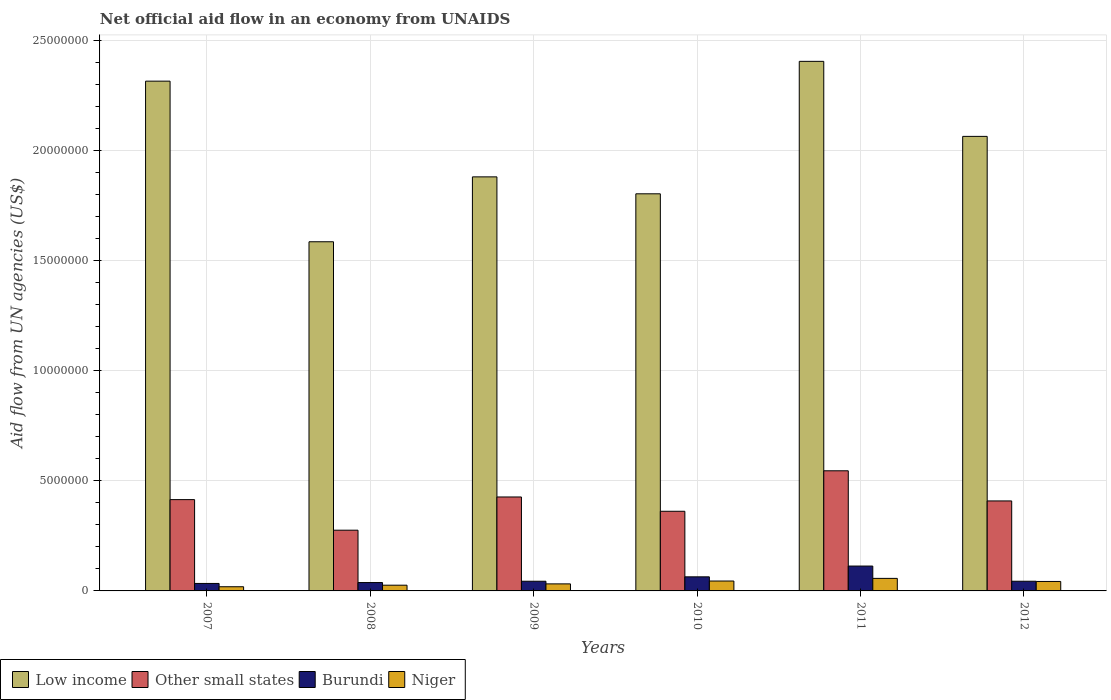How many different coloured bars are there?
Your answer should be compact. 4. How many groups of bars are there?
Your response must be concise. 6. In how many cases, is the number of bars for a given year not equal to the number of legend labels?
Give a very brief answer. 0. What is the net official aid flow in Niger in 2008?
Give a very brief answer. 2.60e+05. Across all years, what is the maximum net official aid flow in Niger?
Your answer should be very brief. 5.70e+05. Across all years, what is the minimum net official aid flow in Low income?
Provide a succinct answer. 1.59e+07. What is the total net official aid flow in Low income in the graph?
Make the answer very short. 1.21e+08. What is the difference between the net official aid flow in Burundi in 2007 and that in 2011?
Ensure brevity in your answer.  -7.90e+05. What is the difference between the net official aid flow in Niger in 2008 and the net official aid flow in Other small states in 2011?
Offer a very short reply. -5.20e+06. What is the average net official aid flow in Other small states per year?
Give a very brief answer. 4.06e+06. In the year 2008, what is the difference between the net official aid flow in Low income and net official aid flow in Niger?
Keep it short and to the point. 1.56e+07. What is the ratio of the net official aid flow in Low income in 2010 to that in 2011?
Your response must be concise. 0.75. Is the net official aid flow in Burundi in 2011 less than that in 2012?
Offer a very short reply. No. Is the difference between the net official aid flow in Low income in 2007 and 2010 greater than the difference between the net official aid flow in Niger in 2007 and 2010?
Your answer should be compact. Yes. What is the difference between the highest and the lowest net official aid flow in Other small states?
Keep it short and to the point. 2.70e+06. Is it the case that in every year, the sum of the net official aid flow in Burundi and net official aid flow in Low income is greater than the sum of net official aid flow in Other small states and net official aid flow in Niger?
Offer a terse response. Yes. What does the 2nd bar from the left in 2012 represents?
Give a very brief answer. Other small states. What does the 1st bar from the right in 2007 represents?
Your answer should be very brief. Niger. Is it the case that in every year, the sum of the net official aid flow in Low income and net official aid flow in Burundi is greater than the net official aid flow in Other small states?
Provide a short and direct response. Yes. Are all the bars in the graph horizontal?
Make the answer very short. No. How many years are there in the graph?
Give a very brief answer. 6. Does the graph contain any zero values?
Provide a short and direct response. No. Does the graph contain grids?
Offer a terse response. Yes. What is the title of the graph?
Give a very brief answer. Net official aid flow in an economy from UNAIDS. What is the label or title of the X-axis?
Make the answer very short. Years. What is the label or title of the Y-axis?
Your answer should be compact. Aid flow from UN agencies (US$). What is the Aid flow from UN agencies (US$) of Low income in 2007?
Ensure brevity in your answer.  2.32e+07. What is the Aid flow from UN agencies (US$) in Other small states in 2007?
Keep it short and to the point. 4.15e+06. What is the Aid flow from UN agencies (US$) of Low income in 2008?
Your answer should be very brief. 1.59e+07. What is the Aid flow from UN agencies (US$) in Other small states in 2008?
Keep it short and to the point. 2.76e+06. What is the Aid flow from UN agencies (US$) in Burundi in 2008?
Make the answer very short. 3.80e+05. What is the Aid flow from UN agencies (US$) of Low income in 2009?
Offer a terse response. 1.88e+07. What is the Aid flow from UN agencies (US$) in Other small states in 2009?
Your answer should be very brief. 4.27e+06. What is the Aid flow from UN agencies (US$) of Niger in 2009?
Make the answer very short. 3.20e+05. What is the Aid flow from UN agencies (US$) of Low income in 2010?
Offer a terse response. 1.80e+07. What is the Aid flow from UN agencies (US$) of Other small states in 2010?
Offer a terse response. 3.62e+06. What is the Aid flow from UN agencies (US$) of Burundi in 2010?
Make the answer very short. 6.40e+05. What is the Aid flow from UN agencies (US$) in Low income in 2011?
Make the answer very short. 2.41e+07. What is the Aid flow from UN agencies (US$) of Other small states in 2011?
Provide a succinct answer. 5.46e+06. What is the Aid flow from UN agencies (US$) of Burundi in 2011?
Your answer should be compact. 1.13e+06. What is the Aid flow from UN agencies (US$) of Niger in 2011?
Give a very brief answer. 5.70e+05. What is the Aid flow from UN agencies (US$) in Low income in 2012?
Offer a very short reply. 2.07e+07. What is the Aid flow from UN agencies (US$) in Other small states in 2012?
Your response must be concise. 4.09e+06. Across all years, what is the maximum Aid flow from UN agencies (US$) of Low income?
Provide a succinct answer. 2.41e+07. Across all years, what is the maximum Aid flow from UN agencies (US$) in Other small states?
Offer a very short reply. 5.46e+06. Across all years, what is the maximum Aid flow from UN agencies (US$) in Burundi?
Ensure brevity in your answer.  1.13e+06. Across all years, what is the maximum Aid flow from UN agencies (US$) in Niger?
Your answer should be compact. 5.70e+05. Across all years, what is the minimum Aid flow from UN agencies (US$) of Low income?
Offer a very short reply. 1.59e+07. Across all years, what is the minimum Aid flow from UN agencies (US$) of Other small states?
Your answer should be very brief. 2.76e+06. What is the total Aid flow from UN agencies (US$) in Low income in the graph?
Make the answer very short. 1.21e+08. What is the total Aid flow from UN agencies (US$) in Other small states in the graph?
Provide a short and direct response. 2.44e+07. What is the total Aid flow from UN agencies (US$) of Burundi in the graph?
Your answer should be very brief. 3.37e+06. What is the total Aid flow from UN agencies (US$) of Niger in the graph?
Provide a succinct answer. 2.22e+06. What is the difference between the Aid flow from UN agencies (US$) in Low income in 2007 and that in 2008?
Your answer should be compact. 7.30e+06. What is the difference between the Aid flow from UN agencies (US$) of Other small states in 2007 and that in 2008?
Provide a succinct answer. 1.39e+06. What is the difference between the Aid flow from UN agencies (US$) of Niger in 2007 and that in 2008?
Make the answer very short. -7.00e+04. What is the difference between the Aid flow from UN agencies (US$) in Low income in 2007 and that in 2009?
Offer a terse response. 4.35e+06. What is the difference between the Aid flow from UN agencies (US$) in Burundi in 2007 and that in 2009?
Keep it short and to the point. -1.00e+05. What is the difference between the Aid flow from UN agencies (US$) of Niger in 2007 and that in 2009?
Ensure brevity in your answer.  -1.30e+05. What is the difference between the Aid flow from UN agencies (US$) of Low income in 2007 and that in 2010?
Offer a terse response. 5.12e+06. What is the difference between the Aid flow from UN agencies (US$) in Other small states in 2007 and that in 2010?
Your response must be concise. 5.30e+05. What is the difference between the Aid flow from UN agencies (US$) in Low income in 2007 and that in 2011?
Ensure brevity in your answer.  -9.00e+05. What is the difference between the Aid flow from UN agencies (US$) of Other small states in 2007 and that in 2011?
Make the answer very short. -1.31e+06. What is the difference between the Aid flow from UN agencies (US$) in Burundi in 2007 and that in 2011?
Provide a succinct answer. -7.90e+05. What is the difference between the Aid flow from UN agencies (US$) of Niger in 2007 and that in 2011?
Your answer should be compact. -3.80e+05. What is the difference between the Aid flow from UN agencies (US$) in Low income in 2007 and that in 2012?
Keep it short and to the point. 2.51e+06. What is the difference between the Aid flow from UN agencies (US$) of Low income in 2008 and that in 2009?
Give a very brief answer. -2.95e+06. What is the difference between the Aid flow from UN agencies (US$) in Other small states in 2008 and that in 2009?
Keep it short and to the point. -1.51e+06. What is the difference between the Aid flow from UN agencies (US$) in Burundi in 2008 and that in 2009?
Provide a succinct answer. -6.00e+04. What is the difference between the Aid flow from UN agencies (US$) of Niger in 2008 and that in 2009?
Make the answer very short. -6.00e+04. What is the difference between the Aid flow from UN agencies (US$) of Low income in 2008 and that in 2010?
Your response must be concise. -2.18e+06. What is the difference between the Aid flow from UN agencies (US$) in Other small states in 2008 and that in 2010?
Provide a short and direct response. -8.60e+05. What is the difference between the Aid flow from UN agencies (US$) of Niger in 2008 and that in 2010?
Your response must be concise. -1.90e+05. What is the difference between the Aid flow from UN agencies (US$) in Low income in 2008 and that in 2011?
Make the answer very short. -8.20e+06. What is the difference between the Aid flow from UN agencies (US$) in Other small states in 2008 and that in 2011?
Provide a short and direct response. -2.70e+06. What is the difference between the Aid flow from UN agencies (US$) of Burundi in 2008 and that in 2011?
Keep it short and to the point. -7.50e+05. What is the difference between the Aid flow from UN agencies (US$) of Niger in 2008 and that in 2011?
Provide a succinct answer. -3.10e+05. What is the difference between the Aid flow from UN agencies (US$) in Low income in 2008 and that in 2012?
Keep it short and to the point. -4.79e+06. What is the difference between the Aid flow from UN agencies (US$) of Other small states in 2008 and that in 2012?
Your answer should be very brief. -1.33e+06. What is the difference between the Aid flow from UN agencies (US$) of Burundi in 2008 and that in 2012?
Make the answer very short. -6.00e+04. What is the difference between the Aid flow from UN agencies (US$) in Niger in 2008 and that in 2012?
Offer a terse response. -1.70e+05. What is the difference between the Aid flow from UN agencies (US$) of Low income in 2009 and that in 2010?
Your answer should be very brief. 7.70e+05. What is the difference between the Aid flow from UN agencies (US$) in Other small states in 2009 and that in 2010?
Your answer should be compact. 6.50e+05. What is the difference between the Aid flow from UN agencies (US$) in Burundi in 2009 and that in 2010?
Make the answer very short. -2.00e+05. What is the difference between the Aid flow from UN agencies (US$) in Low income in 2009 and that in 2011?
Ensure brevity in your answer.  -5.25e+06. What is the difference between the Aid flow from UN agencies (US$) in Other small states in 2009 and that in 2011?
Provide a succinct answer. -1.19e+06. What is the difference between the Aid flow from UN agencies (US$) in Burundi in 2009 and that in 2011?
Give a very brief answer. -6.90e+05. What is the difference between the Aid flow from UN agencies (US$) in Niger in 2009 and that in 2011?
Make the answer very short. -2.50e+05. What is the difference between the Aid flow from UN agencies (US$) in Low income in 2009 and that in 2012?
Make the answer very short. -1.84e+06. What is the difference between the Aid flow from UN agencies (US$) in Low income in 2010 and that in 2011?
Make the answer very short. -6.02e+06. What is the difference between the Aid flow from UN agencies (US$) of Other small states in 2010 and that in 2011?
Provide a succinct answer. -1.84e+06. What is the difference between the Aid flow from UN agencies (US$) of Burundi in 2010 and that in 2011?
Provide a succinct answer. -4.90e+05. What is the difference between the Aid flow from UN agencies (US$) of Low income in 2010 and that in 2012?
Keep it short and to the point. -2.61e+06. What is the difference between the Aid flow from UN agencies (US$) of Other small states in 2010 and that in 2012?
Make the answer very short. -4.70e+05. What is the difference between the Aid flow from UN agencies (US$) in Niger in 2010 and that in 2012?
Offer a terse response. 2.00e+04. What is the difference between the Aid flow from UN agencies (US$) in Low income in 2011 and that in 2012?
Provide a short and direct response. 3.41e+06. What is the difference between the Aid flow from UN agencies (US$) in Other small states in 2011 and that in 2012?
Your answer should be compact. 1.37e+06. What is the difference between the Aid flow from UN agencies (US$) in Burundi in 2011 and that in 2012?
Provide a succinct answer. 6.90e+05. What is the difference between the Aid flow from UN agencies (US$) in Low income in 2007 and the Aid flow from UN agencies (US$) in Other small states in 2008?
Your response must be concise. 2.04e+07. What is the difference between the Aid flow from UN agencies (US$) in Low income in 2007 and the Aid flow from UN agencies (US$) in Burundi in 2008?
Offer a terse response. 2.28e+07. What is the difference between the Aid flow from UN agencies (US$) in Low income in 2007 and the Aid flow from UN agencies (US$) in Niger in 2008?
Your answer should be compact. 2.29e+07. What is the difference between the Aid flow from UN agencies (US$) in Other small states in 2007 and the Aid flow from UN agencies (US$) in Burundi in 2008?
Your answer should be compact. 3.77e+06. What is the difference between the Aid flow from UN agencies (US$) of Other small states in 2007 and the Aid flow from UN agencies (US$) of Niger in 2008?
Ensure brevity in your answer.  3.89e+06. What is the difference between the Aid flow from UN agencies (US$) of Low income in 2007 and the Aid flow from UN agencies (US$) of Other small states in 2009?
Offer a terse response. 1.89e+07. What is the difference between the Aid flow from UN agencies (US$) of Low income in 2007 and the Aid flow from UN agencies (US$) of Burundi in 2009?
Offer a very short reply. 2.27e+07. What is the difference between the Aid flow from UN agencies (US$) of Low income in 2007 and the Aid flow from UN agencies (US$) of Niger in 2009?
Make the answer very short. 2.28e+07. What is the difference between the Aid flow from UN agencies (US$) of Other small states in 2007 and the Aid flow from UN agencies (US$) of Burundi in 2009?
Offer a very short reply. 3.71e+06. What is the difference between the Aid flow from UN agencies (US$) of Other small states in 2007 and the Aid flow from UN agencies (US$) of Niger in 2009?
Your answer should be compact. 3.83e+06. What is the difference between the Aid flow from UN agencies (US$) in Burundi in 2007 and the Aid flow from UN agencies (US$) in Niger in 2009?
Provide a short and direct response. 2.00e+04. What is the difference between the Aid flow from UN agencies (US$) of Low income in 2007 and the Aid flow from UN agencies (US$) of Other small states in 2010?
Your answer should be very brief. 1.96e+07. What is the difference between the Aid flow from UN agencies (US$) of Low income in 2007 and the Aid flow from UN agencies (US$) of Burundi in 2010?
Ensure brevity in your answer.  2.25e+07. What is the difference between the Aid flow from UN agencies (US$) of Low income in 2007 and the Aid flow from UN agencies (US$) of Niger in 2010?
Provide a succinct answer. 2.27e+07. What is the difference between the Aid flow from UN agencies (US$) in Other small states in 2007 and the Aid flow from UN agencies (US$) in Burundi in 2010?
Offer a very short reply. 3.51e+06. What is the difference between the Aid flow from UN agencies (US$) in Other small states in 2007 and the Aid flow from UN agencies (US$) in Niger in 2010?
Provide a short and direct response. 3.70e+06. What is the difference between the Aid flow from UN agencies (US$) of Burundi in 2007 and the Aid flow from UN agencies (US$) of Niger in 2010?
Give a very brief answer. -1.10e+05. What is the difference between the Aid flow from UN agencies (US$) of Low income in 2007 and the Aid flow from UN agencies (US$) of Other small states in 2011?
Offer a very short reply. 1.77e+07. What is the difference between the Aid flow from UN agencies (US$) of Low income in 2007 and the Aid flow from UN agencies (US$) of Burundi in 2011?
Your answer should be compact. 2.20e+07. What is the difference between the Aid flow from UN agencies (US$) in Low income in 2007 and the Aid flow from UN agencies (US$) in Niger in 2011?
Your answer should be very brief. 2.26e+07. What is the difference between the Aid flow from UN agencies (US$) of Other small states in 2007 and the Aid flow from UN agencies (US$) of Burundi in 2011?
Ensure brevity in your answer.  3.02e+06. What is the difference between the Aid flow from UN agencies (US$) in Other small states in 2007 and the Aid flow from UN agencies (US$) in Niger in 2011?
Offer a terse response. 3.58e+06. What is the difference between the Aid flow from UN agencies (US$) in Burundi in 2007 and the Aid flow from UN agencies (US$) in Niger in 2011?
Offer a very short reply. -2.30e+05. What is the difference between the Aid flow from UN agencies (US$) of Low income in 2007 and the Aid flow from UN agencies (US$) of Other small states in 2012?
Your answer should be compact. 1.91e+07. What is the difference between the Aid flow from UN agencies (US$) in Low income in 2007 and the Aid flow from UN agencies (US$) in Burundi in 2012?
Your answer should be very brief. 2.27e+07. What is the difference between the Aid flow from UN agencies (US$) in Low income in 2007 and the Aid flow from UN agencies (US$) in Niger in 2012?
Keep it short and to the point. 2.27e+07. What is the difference between the Aid flow from UN agencies (US$) in Other small states in 2007 and the Aid flow from UN agencies (US$) in Burundi in 2012?
Your answer should be very brief. 3.71e+06. What is the difference between the Aid flow from UN agencies (US$) in Other small states in 2007 and the Aid flow from UN agencies (US$) in Niger in 2012?
Ensure brevity in your answer.  3.72e+06. What is the difference between the Aid flow from UN agencies (US$) of Low income in 2008 and the Aid flow from UN agencies (US$) of Other small states in 2009?
Your response must be concise. 1.16e+07. What is the difference between the Aid flow from UN agencies (US$) in Low income in 2008 and the Aid flow from UN agencies (US$) in Burundi in 2009?
Offer a very short reply. 1.54e+07. What is the difference between the Aid flow from UN agencies (US$) in Low income in 2008 and the Aid flow from UN agencies (US$) in Niger in 2009?
Give a very brief answer. 1.56e+07. What is the difference between the Aid flow from UN agencies (US$) in Other small states in 2008 and the Aid flow from UN agencies (US$) in Burundi in 2009?
Keep it short and to the point. 2.32e+06. What is the difference between the Aid flow from UN agencies (US$) in Other small states in 2008 and the Aid flow from UN agencies (US$) in Niger in 2009?
Provide a succinct answer. 2.44e+06. What is the difference between the Aid flow from UN agencies (US$) in Burundi in 2008 and the Aid flow from UN agencies (US$) in Niger in 2009?
Your response must be concise. 6.00e+04. What is the difference between the Aid flow from UN agencies (US$) of Low income in 2008 and the Aid flow from UN agencies (US$) of Other small states in 2010?
Offer a very short reply. 1.22e+07. What is the difference between the Aid flow from UN agencies (US$) in Low income in 2008 and the Aid flow from UN agencies (US$) in Burundi in 2010?
Offer a very short reply. 1.52e+07. What is the difference between the Aid flow from UN agencies (US$) in Low income in 2008 and the Aid flow from UN agencies (US$) in Niger in 2010?
Your answer should be very brief. 1.54e+07. What is the difference between the Aid flow from UN agencies (US$) of Other small states in 2008 and the Aid flow from UN agencies (US$) of Burundi in 2010?
Your answer should be very brief. 2.12e+06. What is the difference between the Aid flow from UN agencies (US$) in Other small states in 2008 and the Aid flow from UN agencies (US$) in Niger in 2010?
Your response must be concise. 2.31e+06. What is the difference between the Aid flow from UN agencies (US$) in Burundi in 2008 and the Aid flow from UN agencies (US$) in Niger in 2010?
Your answer should be very brief. -7.00e+04. What is the difference between the Aid flow from UN agencies (US$) of Low income in 2008 and the Aid flow from UN agencies (US$) of Other small states in 2011?
Provide a succinct answer. 1.04e+07. What is the difference between the Aid flow from UN agencies (US$) in Low income in 2008 and the Aid flow from UN agencies (US$) in Burundi in 2011?
Your answer should be compact. 1.47e+07. What is the difference between the Aid flow from UN agencies (US$) in Low income in 2008 and the Aid flow from UN agencies (US$) in Niger in 2011?
Provide a short and direct response. 1.53e+07. What is the difference between the Aid flow from UN agencies (US$) of Other small states in 2008 and the Aid flow from UN agencies (US$) of Burundi in 2011?
Your answer should be compact. 1.63e+06. What is the difference between the Aid flow from UN agencies (US$) in Other small states in 2008 and the Aid flow from UN agencies (US$) in Niger in 2011?
Provide a short and direct response. 2.19e+06. What is the difference between the Aid flow from UN agencies (US$) of Burundi in 2008 and the Aid flow from UN agencies (US$) of Niger in 2011?
Offer a very short reply. -1.90e+05. What is the difference between the Aid flow from UN agencies (US$) in Low income in 2008 and the Aid flow from UN agencies (US$) in Other small states in 2012?
Your response must be concise. 1.18e+07. What is the difference between the Aid flow from UN agencies (US$) of Low income in 2008 and the Aid flow from UN agencies (US$) of Burundi in 2012?
Your answer should be very brief. 1.54e+07. What is the difference between the Aid flow from UN agencies (US$) of Low income in 2008 and the Aid flow from UN agencies (US$) of Niger in 2012?
Keep it short and to the point. 1.54e+07. What is the difference between the Aid flow from UN agencies (US$) of Other small states in 2008 and the Aid flow from UN agencies (US$) of Burundi in 2012?
Offer a terse response. 2.32e+06. What is the difference between the Aid flow from UN agencies (US$) in Other small states in 2008 and the Aid flow from UN agencies (US$) in Niger in 2012?
Provide a short and direct response. 2.33e+06. What is the difference between the Aid flow from UN agencies (US$) of Low income in 2009 and the Aid flow from UN agencies (US$) of Other small states in 2010?
Your answer should be compact. 1.52e+07. What is the difference between the Aid flow from UN agencies (US$) of Low income in 2009 and the Aid flow from UN agencies (US$) of Burundi in 2010?
Give a very brief answer. 1.82e+07. What is the difference between the Aid flow from UN agencies (US$) in Low income in 2009 and the Aid flow from UN agencies (US$) in Niger in 2010?
Offer a terse response. 1.84e+07. What is the difference between the Aid flow from UN agencies (US$) in Other small states in 2009 and the Aid flow from UN agencies (US$) in Burundi in 2010?
Ensure brevity in your answer.  3.63e+06. What is the difference between the Aid flow from UN agencies (US$) of Other small states in 2009 and the Aid flow from UN agencies (US$) of Niger in 2010?
Ensure brevity in your answer.  3.82e+06. What is the difference between the Aid flow from UN agencies (US$) of Low income in 2009 and the Aid flow from UN agencies (US$) of Other small states in 2011?
Your answer should be very brief. 1.34e+07. What is the difference between the Aid flow from UN agencies (US$) in Low income in 2009 and the Aid flow from UN agencies (US$) in Burundi in 2011?
Offer a very short reply. 1.77e+07. What is the difference between the Aid flow from UN agencies (US$) of Low income in 2009 and the Aid flow from UN agencies (US$) of Niger in 2011?
Offer a terse response. 1.82e+07. What is the difference between the Aid flow from UN agencies (US$) of Other small states in 2009 and the Aid flow from UN agencies (US$) of Burundi in 2011?
Your answer should be compact. 3.14e+06. What is the difference between the Aid flow from UN agencies (US$) of Other small states in 2009 and the Aid flow from UN agencies (US$) of Niger in 2011?
Provide a succinct answer. 3.70e+06. What is the difference between the Aid flow from UN agencies (US$) of Burundi in 2009 and the Aid flow from UN agencies (US$) of Niger in 2011?
Keep it short and to the point. -1.30e+05. What is the difference between the Aid flow from UN agencies (US$) in Low income in 2009 and the Aid flow from UN agencies (US$) in Other small states in 2012?
Your answer should be compact. 1.47e+07. What is the difference between the Aid flow from UN agencies (US$) of Low income in 2009 and the Aid flow from UN agencies (US$) of Burundi in 2012?
Keep it short and to the point. 1.84e+07. What is the difference between the Aid flow from UN agencies (US$) in Low income in 2009 and the Aid flow from UN agencies (US$) in Niger in 2012?
Ensure brevity in your answer.  1.84e+07. What is the difference between the Aid flow from UN agencies (US$) of Other small states in 2009 and the Aid flow from UN agencies (US$) of Burundi in 2012?
Keep it short and to the point. 3.83e+06. What is the difference between the Aid flow from UN agencies (US$) of Other small states in 2009 and the Aid flow from UN agencies (US$) of Niger in 2012?
Provide a short and direct response. 3.84e+06. What is the difference between the Aid flow from UN agencies (US$) of Low income in 2010 and the Aid flow from UN agencies (US$) of Other small states in 2011?
Offer a terse response. 1.26e+07. What is the difference between the Aid flow from UN agencies (US$) in Low income in 2010 and the Aid flow from UN agencies (US$) in Burundi in 2011?
Provide a succinct answer. 1.69e+07. What is the difference between the Aid flow from UN agencies (US$) in Low income in 2010 and the Aid flow from UN agencies (US$) in Niger in 2011?
Give a very brief answer. 1.75e+07. What is the difference between the Aid flow from UN agencies (US$) in Other small states in 2010 and the Aid flow from UN agencies (US$) in Burundi in 2011?
Provide a succinct answer. 2.49e+06. What is the difference between the Aid flow from UN agencies (US$) of Other small states in 2010 and the Aid flow from UN agencies (US$) of Niger in 2011?
Make the answer very short. 3.05e+06. What is the difference between the Aid flow from UN agencies (US$) of Burundi in 2010 and the Aid flow from UN agencies (US$) of Niger in 2011?
Your response must be concise. 7.00e+04. What is the difference between the Aid flow from UN agencies (US$) in Low income in 2010 and the Aid flow from UN agencies (US$) in Other small states in 2012?
Provide a succinct answer. 1.40e+07. What is the difference between the Aid flow from UN agencies (US$) in Low income in 2010 and the Aid flow from UN agencies (US$) in Burundi in 2012?
Keep it short and to the point. 1.76e+07. What is the difference between the Aid flow from UN agencies (US$) in Low income in 2010 and the Aid flow from UN agencies (US$) in Niger in 2012?
Ensure brevity in your answer.  1.76e+07. What is the difference between the Aid flow from UN agencies (US$) of Other small states in 2010 and the Aid flow from UN agencies (US$) of Burundi in 2012?
Make the answer very short. 3.18e+06. What is the difference between the Aid flow from UN agencies (US$) of Other small states in 2010 and the Aid flow from UN agencies (US$) of Niger in 2012?
Ensure brevity in your answer.  3.19e+06. What is the difference between the Aid flow from UN agencies (US$) of Burundi in 2010 and the Aid flow from UN agencies (US$) of Niger in 2012?
Provide a short and direct response. 2.10e+05. What is the difference between the Aid flow from UN agencies (US$) in Low income in 2011 and the Aid flow from UN agencies (US$) in Other small states in 2012?
Your answer should be compact. 2.00e+07. What is the difference between the Aid flow from UN agencies (US$) in Low income in 2011 and the Aid flow from UN agencies (US$) in Burundi in 2012?
Provide a short and direct response. 2.36e+07. What is the difference between the Aid flow from UN agencies (US$) of Low income in 2011 and the Aid flow from UN agencies (US$) of Niger in 2012?
Offer a very short reply. 2.36e+07. What is the difference between the Aid flow from UN agencies (US$) in Other small states in 2011 and the Aid flow from UN agencies (US$) in Burundi in 2012?
Your answer should be very brief. 5.02e+06. What is the difference between the Aid flow from UN agencies (US$) in Other small states in 2011 and the Aid flow from UN agencies (US$) in Niger in 2012?
Provide a succinct answer. 5.03e+06. What is the difference between the Aid flow from UN agencies (US$) in Burundi in 2011 and the Aid flow from UN agencies (US$) in Niger in 2012?
Provide a short and direct response. 7.00e+05. What is the average Aid flow from UN agencies (US$) in Low income per year?
Your answer should be very brief. 2.01e+07. What is the average Aid flow from UN agencies (US$) of Other small states per year?
Your answer should be very brief. 4.06e+06. What is the average Aid flow from UN agencies (US$) of Burundi per year?
Your answer should be very brief. 5.62e+05. In the year 2007, what is the difference between the Aid flow from UN agencies (US$) of Low income and Aid flow from UN agencies (US$) of Other small states?
Your response must be concise. 1.90e+07. In the year 2007, what is the difference between the Aid flow from UN agencies (US$) of Low income and Aid flow from UN agencies (US$) of Burundi?
Your answer should be compact. 2.28e+07. In the year 2007, what is the difference between the Aid flow from UN agencies (US$) of Low income and Aid flow from UN agencies (US$) of Niger?
Keep it short and to the point. 2.30e+07. In the year 2007, what is the difference between the Aid flow from UN agencies (US$) in Other small states and Aid flow from UN agencies (US$) in Burundi?
Provide a succinct answer. 3.81e+06. In the year 2007, what is the difference between the Aid flow from UN agencies (US$) in Other small states and Aid flow from UN agencies (US$) in Niger?
Make the answer very short. 3.96e+06. In the year 2008, what is the difference between the Aid flow from UN agencies (US$) in Low income and Aid flow from UN agencies (US$) in Other small states?
Provide a short and direct response. 1.31e+07. In the year 2008, what is the difference between the Aid flow from UN agencies (US$) in Low income and Aid flow from UN agencies (US$) in Burundi?
Provide a succinct answer. 1.55e+07. In the year 2008, what is the difference between the Aid flow from UN agencies (US$) of Low income and Aid flow from UN agencies (US$) of Niger?
Ensure brevity in your answer.  1.56e+07. In the year 2008, what is the difference between the Aid flow from UN agencies (US$) in Other small states and Aid flow from UN agencies (US$) in Burundi?
Make the answer very short. 2.38e+06. In the year 2008, what is the difference between the Aid flow from UN agencies (US$) in Other small states and Aid flow from UN agencies (US$) in Niger?
Your answer should be compact. 2.50e+06. In the year 2009, what is the difference between the Aid flow from UN agencies (US$) of Low income and Aid flow from UN agencies (US$) of Other small states?
Make the answer very short. 1.46e+07. In the year 2009, what is the difference between the Aid flow from UN agencies (US$) of Low income and Aid flow from UN agencies (US$) of Burundi?
Provide a succinct answer. 1.84e+07. In the year 2009, what is the difference between the Aid flow from UN agencies (US$) in Low income and Aid flow from UN agencies (US$) in Niger?
Keep it short and to the point. 1.85e+07. In the year 2009, what is the difference between the Aid flow from UN agencies (US$) in Other small states and Aid flow from UN agencies (US$) in Burundi?
Your answer should be compact. 3.83e+06. In the year 2009, what is the difference between the Aid flow from UN agencies (US$) of Other small states and Aid flow from UN agencies (US$) of Niger?
Your answer should be compact. 3.95e+06. In the year 2009, what is the difference between the Aid flow from UN agencies (US$) in Burundi and Aid flow from UN agencies (US$) in Niger?
Ensure brevity in your answer.  1.20e+05. In the year 2010, what is the difference between the Aid flow from UN agencies (US$) of Low income and Aid flow from UN agencies (US$) of Other small states?
Your response must be concise. 1.44e+07. In the year 2010, what is the difference between the Aid flow from UN agencies (US$) of Low income and Aid flow from UN agencies (US$) of Burundi?
Give a very brief answer. 1.74e+07. In the year 2010, what is the difference between the Aid flow from UN agencies (US$) of Low income and Aid flow from UN agencies (US$) of Niger?
Your response must be concise. 1.76e+07. In the year 2010, what is the difference between the Aid flow from UN agencies (US$) of Other small states and Aid flow from UN agencies (US$) of Burundi?
Your answer should be very brief. 2.98e+06. In the year 2010, what is the difference between the Aid flow from UN agencies (US$) in Other small states and Aid flow from UN agencies (US$) in Niger?
Your response must be concise. 3.17e+06. In the year 2010, what is the difference between the Aid flow from UN agencies (US$) in Burundi and Aid flow from UN agencies (US$) in Niger?
Keep it short and to the point. 1.90e+05. In the year 2011, what is the difference between the Aid flow from UN agencies (US$) in Low income and Aid flow from UN agencies (US$) in Other small states?
Give a very brief answer. 1.86e+07. In the year 2011, what is the difference between the Aid flow from UN agencies (US$) in Low income and Aid flow from UN agencies (US$) in Burundi?
Ensure brevity in your answer.  2.29e+07. In the year 2011, what is the difference between the Aid flow from UN agencies (US$) of Low income and Aid flow from UN agencies (US$) of Niger?
Make the answer very short. 2.35e+07. In the year 2011, what is the difference between the Aid flow from UN agencies (US$) in Other small states and Aid flow from UN agencies (US$) in Burundi?
Offer a terse response. 4.33e+06. In the year 2011, what is the difference between the Aid flow from UN agencies (US$) of Other small states and Aid flow from UN agencies (US$) of Niger?
Give a very brief answer. 4.89e+06. In the year 2011, what is the difference between the Aid flow from UN agencies (US$) in Burundi and Aid flow from UN agencies (US$) in Niger?
Make the answer very short. 5.60e+05. In the year 2012, what is the difference between the Aid flow from UN agencies (US$) of Low income and Aid flow from UN agencies (US$) of Other small states?
Offer a terse response. 1.66e+07. In the year 2012, what is the difference between the Aid flow from UN agencies (US$) of Low income and Aid flow from UN agencies (US$) of Burundi?
Provide a short and direct response. 2.02e+07. In the year 2012, what is the difference between the Aid flow from UN agencies (US$) of Low income and Aid flow from UN agencies (US$) of Niger?
Provide a short and direct response. 2.02e+07. In the year 2012, what is the difference between the Aid flow from UN agencies (US$) of Other small states and Aid flow from UN agencies (US$) of Burundi?
Keep it short and to the point. 3.65e+06. In the year 2012, what is the difference between the Aid flow from UN agencies (US$) in Other small states and Aid flow from UN agencies (US$) in Niger?
Your answer should be compact. 3.66e+06. In the year 2012, what is the difference between the Aid flow from UN agencies (US$) of Burundi and Aid flow from UN agencies (US$) of Niger?
Make the answer very short. 10000. What is the ratio of the Aid flow from UN agencies (US$) of Low income in 2007 to that in 2008?
Make the answer very short. 1.46. What is the ratio of the Aid flow from UN agencies (US$) of Other small states in 2007 to that in 2008?
Offer a terse response. 1.5. What is the ratio of the Aid flow from UN agencies (US$) of Burundi in 2007 to that in 2008?
Ensure brevity in your answer.  0.89. What is the ratio of the Aid flow from UN agencies (US$) of Niger in 2007 to that in 2008?
Your answer should be very brief. 0.73. What is the ratio of the Aid flow from UN agencies (US$) of Low income in 2007 to that in 2009?
Give a very brief answer. 1.23. What is the ratio of the Aid flow from UN agencies (US$) in Other small states in 2007 to that in 2009?
Ensure brevity in your answer.  0.97. What is the ratio of the Aid flow from UN agencies (US$) in Burundi in 2007 to that in 2009?
Your answer should be very brief. 0.77. What is the ratio of the Aid flow from UN agencies (US$) of Niger in 2007 to that in 2009?
Keep it short and to the point. 0.59. What is the ratio of the Aid flow from UN agencies (US$) in Low income in 2007 to that in 2010?
Offer a terse response. 1.28. What is the ratio of the Aid flow from UN agencies (US$) in Other small states in 2007 to that in 2010?
Your response must be concise. 1.15. What is the ratio of the Aid flow from UN agencies (US$) of Burundi in 2007 to that in 2010?
Make the answer very short. 0.53. What is the ratio of the Aid flow from UN agencies (US$) in Niger in 2007 to that in 2010?
Ensure brevity in your answer.  0.42. What is the ratio of the Aid flow from UN agencies (US$) of Low income in 2007 to that in 2011?
Give a very brief answer. 0.96. What is the ratio of the Aid flow from UN agencies (US$) of Other small states in 2007 to that in 2011?
Provide a succinct answer. 0.76. What is the ratio of the Aid flow from UN agencies (US$) in Burundi in 2007 to that in 2011?
Offer a very short reply. 0.3. What is the ratio of the Aid flow from UN agencies (US$) in Niger in 2007 to that in 2011?
Your answer should be compact. 0.33. What is the ratio of the Aid flow from UN agencies (US$) in Low income in 2007 to that in 2012?
Provide a succinct answer. 1.12. What is the ratio of the Aid flow from UN agencies (US$) in Other small states in 2007 to that in 2012?
Your answer should be very brief. 1.01. What is the ratio of the Aid flow from UN agencies (US$) in Burundi in 2007 to that in 2012?
Offer a very short reply. 0.77. What is the ratio of the Aid flow from UN agencies (US$) of Niger in 2007 to that in 2012?
Ensure brevity in your answer.  0.44. What is the ratio of the Aid flow from UN agencies (US$) in Low income in 2008 to that in 2009?
Your answer should be very brief. 0.84. What is the ratio of the Aid flow from UN agencies (US$) in Other small states in 2008 to that in 2009?
Provide a succinct answer. 0.65. What is the ratio of the Aid flow from UN agencies (US$) of Burundi in 2008 to that in 2009?
Your response must be concise. 0.86. What is the ratio of the Aid flow from UN agencies (US$) in Niger in 2008 to that in 2009?
Your response must be concise. 0.81. What is the ratio of the Aid flow from UN agencies (US$) of Low income in 2008 to that in 2010?
Offer a terse response. 0.88. What is the ratio of the Aid flow from UN agencies (US$) in Other small states in 2008 to that in 2010?
Offer a very short reply. 0.76. What is the ratio of the Aid flow from UN agencies (US$) of Burundi in 2008 to that in 2010?
Keep it short and to the point. 0.59. What is the ratio of the Aid flow from UN agencies (US$) in Niger in 2008 to that in 2010?
Offer a terse response. 0.58. What is the ratio of the Aid flow from UN agencies (US$) in Low income in 2008 to that in 2011?
Your answer should be compact. 0.66. What is the ratio of the Aid flow from UN agencies (US$) of Other small states in 2008 to that in 2011?
Make the answer very short. 0.51. What is the ratio of the Aid flow from UN agencies (US$) in Burundi in 2008 to that in 2011?
Provide a short and direct response. 0.34. What is the ratio of the Aid flow from UN agencies (US$) of Niger in 2008 to that in 2011?
Offer a terse response. 0.46. What is the ratio of the Aid flow from UN agencies (US$) of Low income in 2008 to that in 2012?
Your response must be concise. 0.77. What is the ratio of the Aid flow from UN agencies (US$) of Other small states in 2008 to that in 2012?
Provide a succinct answer. 0.67. What is the ratio of the Aid flow from UN agencies (US$) of Burundi in 2008 to that in 2012?
Make the answer very short. 0.86. What is the ratio of the Aid flow from UN agencies (US$) of Niger in 2008 to that in 2012?
Offer a terse response. 0.6. What is the ratio of the Aid flow from UN agencies (US$) of Low income in 2009 to that in 2010?
Give a very brief answer. 1.04. What is the ratio of the Aid flow from UN agencies (US$) in Other small states in 2009 to that in 2010?
Keep it short and to the point. 1.18. What is the ratio of the Aid flow from UN agencies (US$) of Burundi in 2009 to that in 2010?
Your answer should be very brief. 0.69. What is the ratio of the Aid flow from UN agencies (US$) of Niger in 2009 to that in 2010?
Offer a terse response. 0.71. What is the ratio of the Aid flow from UN agencies (US$) of Low income in 2009 to that in 2011?
Provide a succinct answer. 0.78. What is the ratio of the Aid flow from UN agencies (US$) of Other small states in 2009 to that in 2011?
Your answer should be compact. 0.78. What is the ratio of the Aid flow from UN agencies (US$) in Burundi in 2009 to that in 2011?
Your response must be concise. 0.39. What is the ratio of the Aid flow from UN agencies (US$) in Niger in 2009 to that in 2011?
Provide a succinct answer. 0.56. What is the ratio of the Aid flow from UN agencies (US$) in Low income in 2009 to that in 2012?
Your answer should be compact. 0.91. What is the ratio of the Aid flow from UN agencies (US$) in Other small states in 2009 to that in 2012?
Ensure brevity in your answer.  1.04. What is the ratio of the Aid flow from UN agencies (US$) of Niger in 2009 to that in 2012?
Provide a succinct answer. 0.74. What is the ratio of the Aid flow from UN agencies (US$) of Low income in 2010 to that in 2011?
Offer a terse response. 0.75. What is the ratio of the Aid flow from UN agencies (US$) of Other small states in 2010 to that in 2011?
Your response must be concise. 0.66. What is the ratio of the Aid flow from UN agencies (US$) of Burundi in 2010 to that in 2011?
Provide a short and direct response. 0.57. What is the ratio of the Aid flow from UN agencies (US$) of Niger in 2010 to that in 2011?
Offer a terse response. 0.79. What is the ratio of the Aid flow from UN agencies (US$) of Low income in 2010 to that in 2012?
Keep it short and to the point. 0.87. What is the ratio of the Aid flow from UN agencies (US$) of Other small states in 2010 to that in 2012?
Your answer should be very brief. 0.89. What is the ratio of the Aid flow from UN agencies (US$) of Burundi in 2010 to that in 2012?
Provide a succinct answer. 1.45. What is the ratio of the Aid flow from UN agencies (US$) of Niger in 2010 to that in 2012?
Offer a very short reply. 1.05. What is the ratio of the Aid flow from UN agencies (US$) in Low income in 2011 to that in 2012?
Give a very brief answer. 1.17. What is the ratio of the Aid flow from UN agencies (US$) of Other small states in 2011 to that in 2012?
Your response must be concise. 1.33. What is the ratio of the Aid flow from UN agencies (US$) in Burundi in 2011 to that in 2012?
Provide a short and direct response. 2.57. What is the ratio of the Aid flow from UN agencies (US$) of Niger in 2011 to that in 2012?
Your response must be concise. 1.33. What is the difference between the highest and the second highest Aid flow from UN agencies (US$) in Low income?
Provide a succinct answer. 9.00e+05. What is the difference between the highest and the second highest Aid flow from UN agencies (US$) in Other small states?
Your answer should be compact. 1.19e+06. What is the difference between the highest and the second highest Aid flow from UN agencies (US$) of Niger?
Offer a terse response. 1.20e+05. What is the difference between the highest and the lowest Aid flow from UN agencies (US$) of Low income?
Provide a short and direct response. 8.20e+06. What is the difference between the highest and the lowest Aid flow from UN agencies (US$) in Other small states?
Your answer should be very brief. 2.70e+06. What is the difference between the highest and the lowest Aid flow from UN agencies (US$) of Burundi?
Make the answer very short. 7.90e+05. 